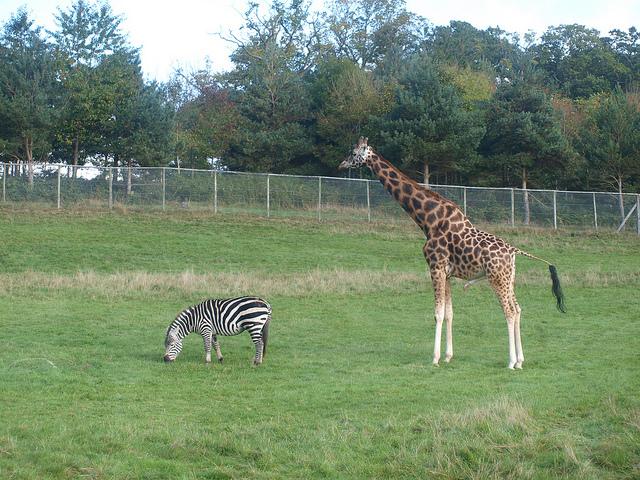How many zebra are there?
Keep it brief. 1. Are the animals in cages?
Short answer required. No. Why is the giraffe's tail sticking straight out?
Give a very brief answer. On alert. Is the giraffe grazing?
Concise answer only. No. Are both of these animals giraffes?
Answer briefly. No. Does the zebra have tail?
Give a very brief answer. Yes. 